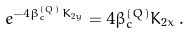Convert formula to latex. <formula><loc_0><loc_0><loc_500><loc_500>e ^ { - 4 \beta ^ { ( Q ) } _ { c } K _ { 2 y } } = 4 \beta ^ { ( Q ) } _ { c } K _ { 2 x } \, .</formula> 